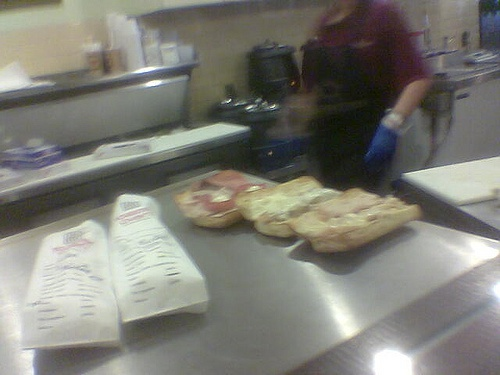Describe the objects in this image and their specific colors. I can see dining table in gray, darkgray, and lightgray tones, people in gray and black tones, hot dog in gray and tan tones, sandwich in gray, tan, and beige tones, and sandwich in gray and tan tones in this image. 